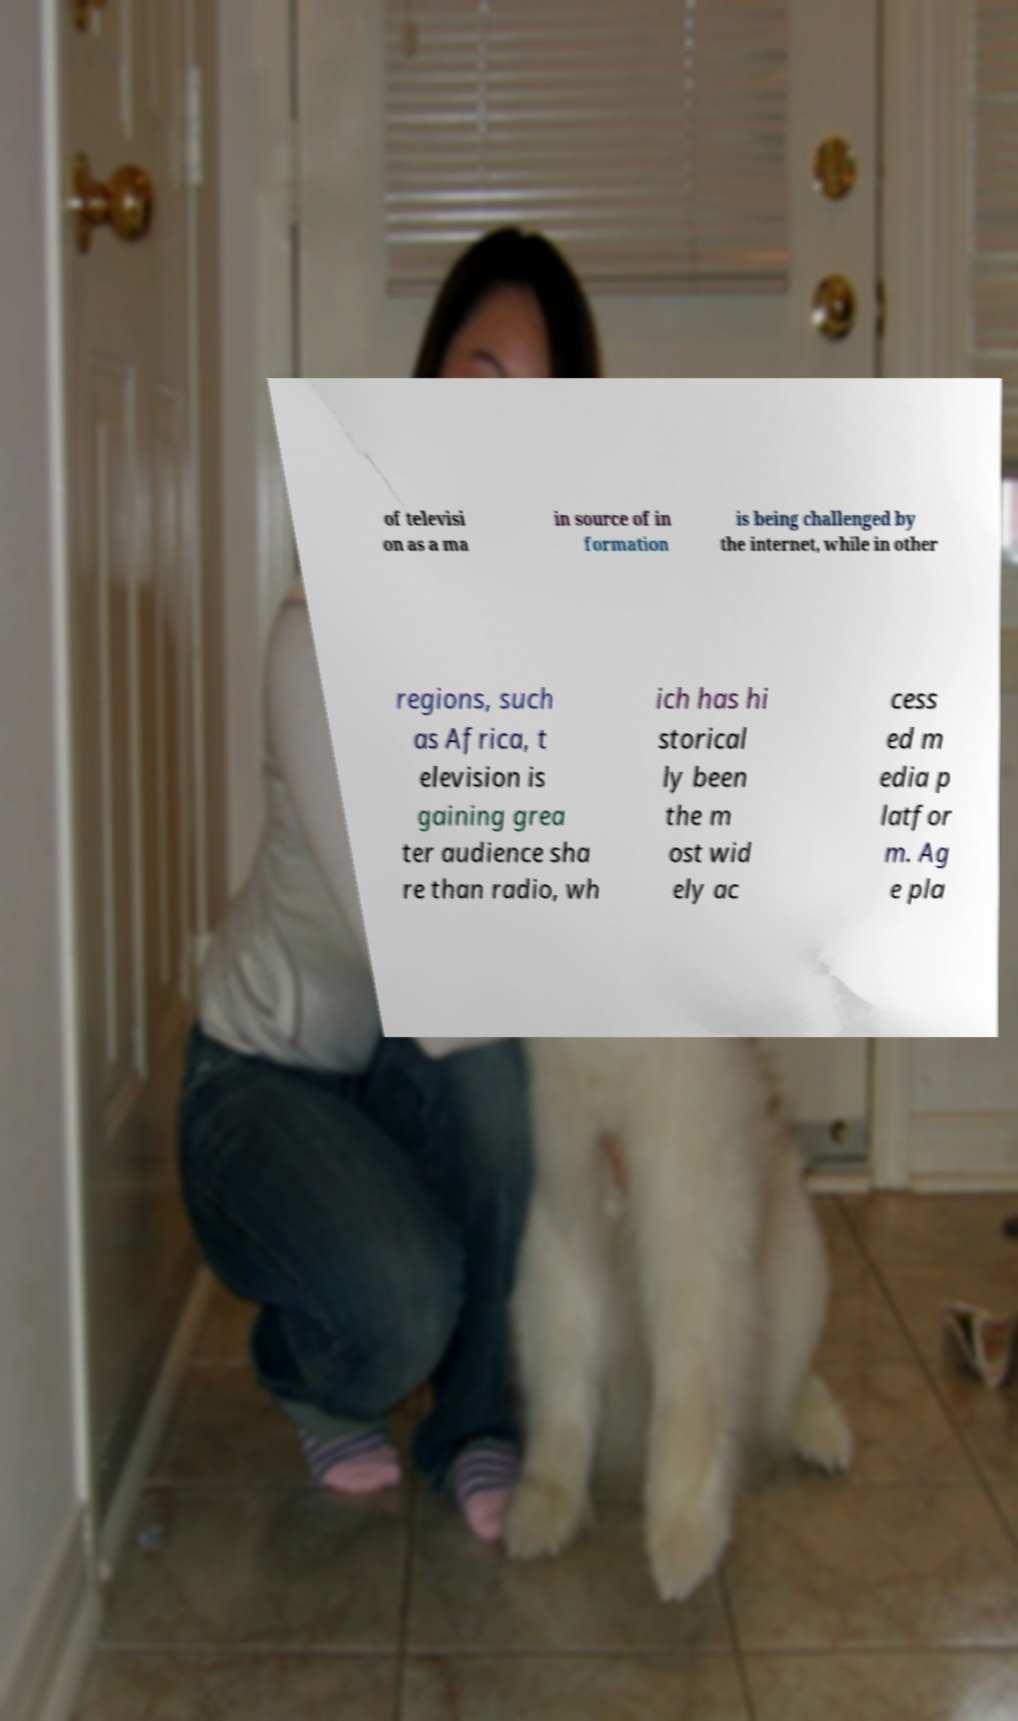What messages or text are displayed in this image? I need them in a readable, typed format. of televisi on as a ma in source of in formation is being challenged by the internet, while in other regions, such as Africa, t elevision is gaining grea ter audience sha re than radio, wh ich has hi storical ly been the m ost wid ely ac cess ed m edia p latfor m. Ag e pla 